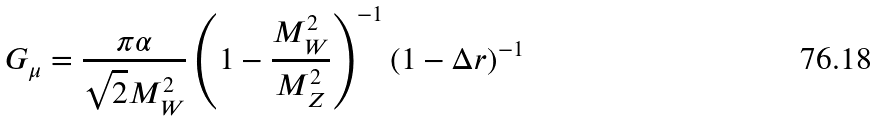<formula> <loc_0><loc_0><loc_500><loc_500>G _ { \mu } = \frac { \pi \alpha } { \sqrt { 2 } M _ { W } ^ { 2 } } \left ( 1 - \frac { M _ { W } ^ { 2 } } { M _ { Z } ^ { 2 } } \right ) ^ { - 1 } ( 1 - \Delta r ) ^ { - 1 }</formula> 